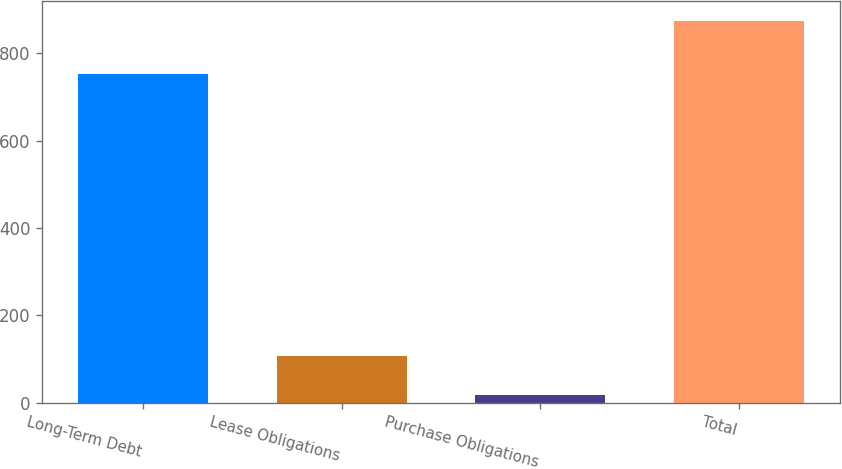<chart> <loc_0><loc_0><loc_500><loc_500><bar_chart><fcel>Long-Term Debt<fcel>Lease Obligations<fcel>Purchase Obligations<fcel>Total<nl><fcel>751.8<fcel>106.9<fcel>16.3<fcel>875<nl></chart> 